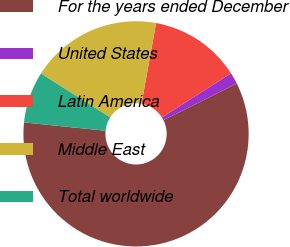<chart> <loc_0><loc_0><loc_500><loc_500><pie_chart><fcel>For the years ended December<fcel>United States<fcel>Latin America<fcel>Middle East<fcel>Total worldwide<nl><fcel>59.0%<fcel>1.65%<fcel>13.12%<fcel>18.85%<fcel>7.38%<nl></chart> 